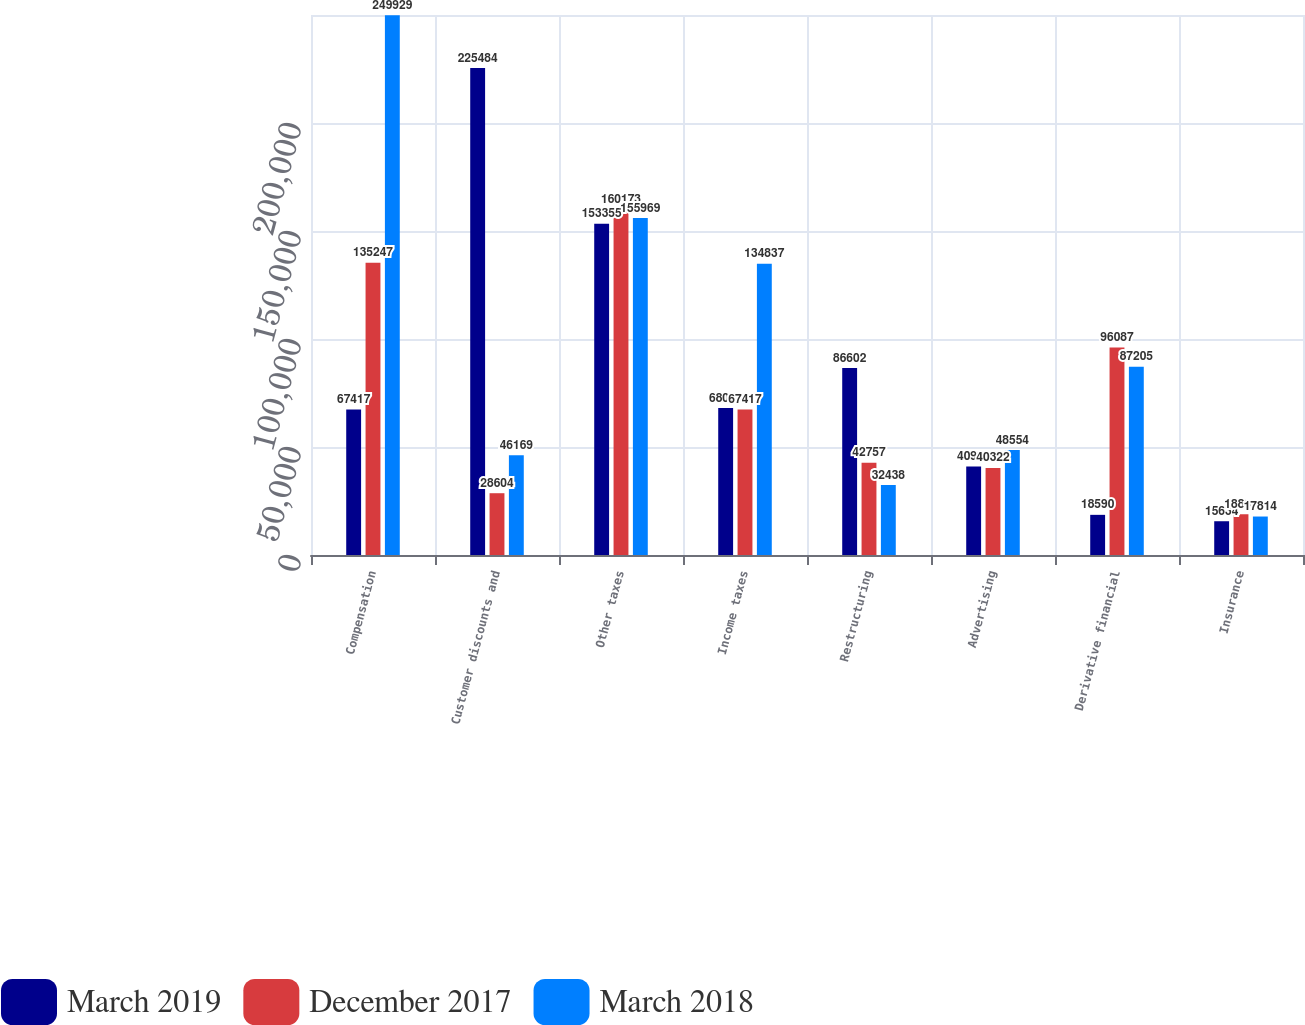<chart> <loc_0><loc_0><loc_500><loc_500><stacked_bar_chart><ecel><fcel>Compensation<fcel>Customer discounts and<fcel>Other taxes<fcel>Income taxes<fcel>Restructuring<fcel>Advertising<fcel>Derivative financial<fcel>Insurance<nl><fcel>March 2019<fcel>67417<fcel>225484<fcel>153355<fcel>68054<fcel>86602<fcel>40938<fcel>18590<fcel>15634<nl><fcel>December 2017<fcel>135247<fcel>28604<fcel>160173<fcel>67417<fcel>42757<fcel>40322<fcel>96087<fcel>18867<nl><fcel>March 2018<fcel>249929<fcel>46169<fcel>155969<fcel>134837<fcel>32438<fcel>48554<fcel>87205<fcel>17814<nl></chart> 